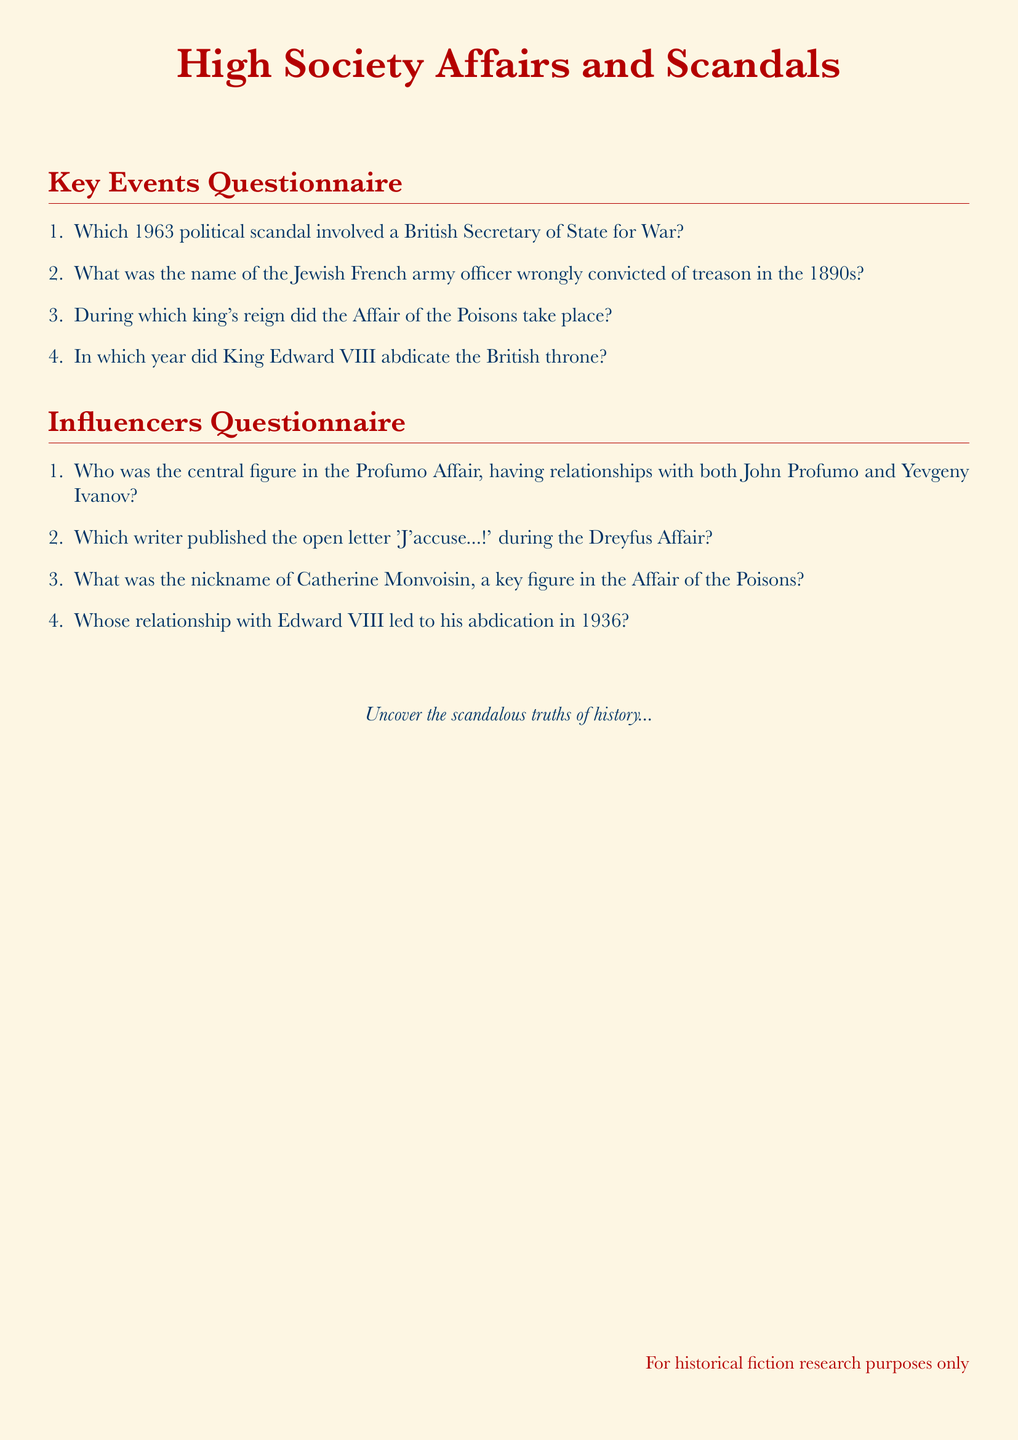Which political scandal involved a British Secretary of State for War? The document specifically states the scandal occurred in 1963, involving a British Secretary of State for War.
Answer: Profumo Affair What year did King Edward VIII abdicate the British throne? The document explicitly mentions the year of King Edward VIII's abdication.
Answer: 1936 Who was the central figure in the Profumo Affair? The document outlines that the central figure had relationships with both John Profumo and Yevgeny Ivanov.
Answer: Christine Keeler What was the name of the Jewish French army officer convicted of treason? The document identifies the officer who was wrongly convicted during the 1890s.
Answer: Alfred Dreyfus During which king's reign did the Affair of the Poisons take place? The document indicates the specific king's reign during which this affair occurred.
Answer: Louis XIV What was the nickname of Catherine Monvoisin? The document lists the nickname associated with Catherine Monvoisin, a key figure in the Affair of the Poisons.
Answer: La Voisin Who published the open letter 'J'accuse...!'? The document attributes the publication of this famous letter to a specific writer during the Dreyfus Affair.
Answer: Émile Zola Whose relationship with Edward VIII led to his abdication? The document explicitly mentions the individual whose relationship caused Edward VIII to abdicate.
Answer: Wallis Simpson 